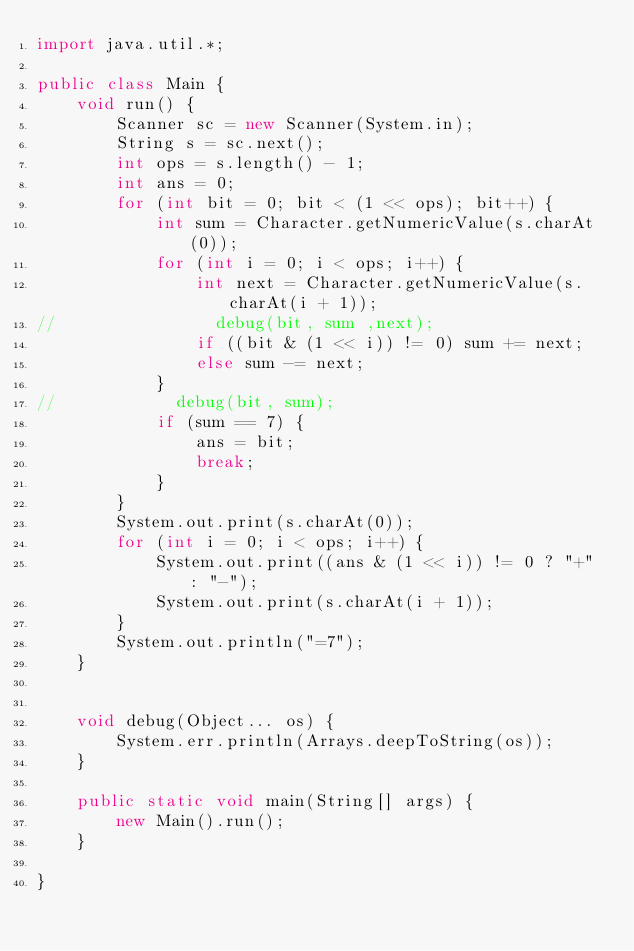<code> <loc_0><loc_0><loc_500><loc_500><_Java_>import java.util.*;

public class Main {
    void run() {
        Scanner sc = new Scanner(System.in);
        String s = sc.next();
        int ops = s.length() - 1;
        int ans = 0;
        for (int bit = 0; bit < (1 << ops); bit++) {
            int sum = Character.getNumericValue(s.charAt(0));
            for (int i = 0; i < ops; i++) {
                int next = Character.getNumericValue(s.charAt(i + 1));
//                debug(bit, sum ,next);
                if ((bit & (1 << i)) != 0) sum += next;
                else sum -= next;
            }
//            debug(bit, sum);
            if (sum == 7) {
                ans = bit;
                break;
            }
        }
        System.out.print(s.charAt(0));
        for (int i = 0; i < ops; i++) {
            System.out.print((ans & (1 << i)) != 0 ? "+" : "-");
            System.out.print(s.charAt(i + 1));
        }
        System.out.println("=7");
    }


    void debug(Object... os) {
        System.err.println(Arrays.deepToString(os));
    }

    public static void main(String[] args) {
        new Main().run();
    }

}
</code> 